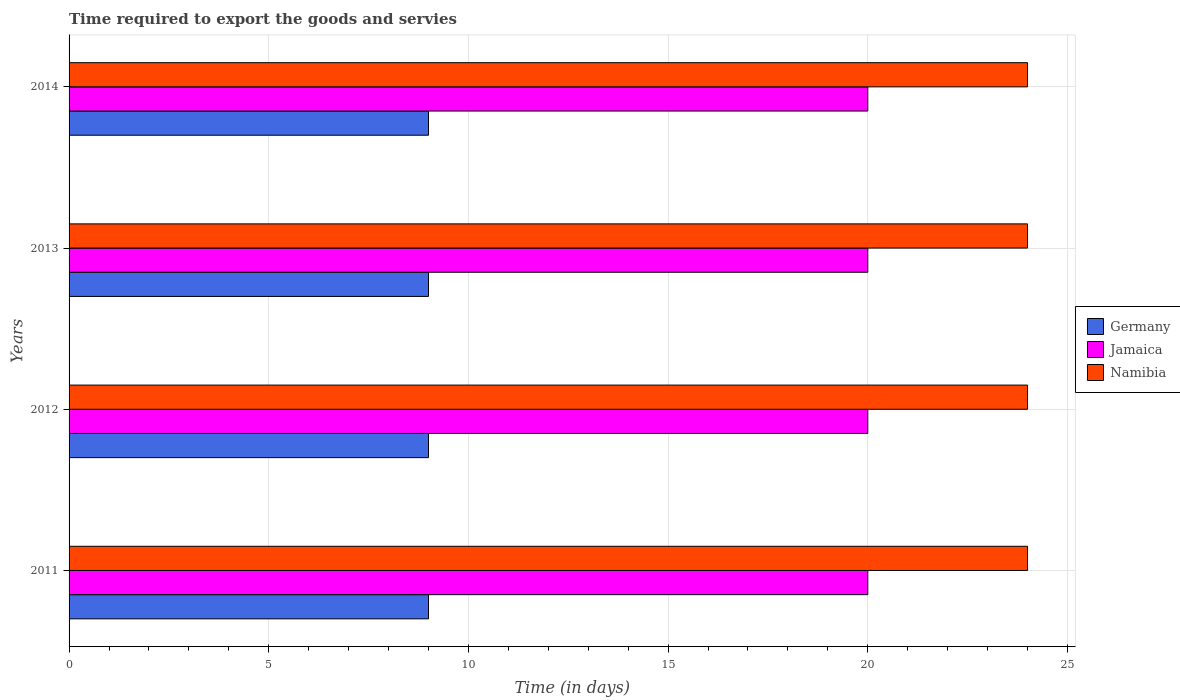How many different coloured bars are there?
Your answer should be compact. 3. Are the number of bars per tick equal to the number of legend labels?
Keep it short and to the point. Yes. Are the number of bars on each tick of the Y-axis equal?
Offer a terse response. Yes. How many bars are there on the 1st tick from the top?
Your answer should be very brief. 3. How many bars are there on the 1st tick from the bottom?
Provide a short and direct response. 3. In how many cases, is the number of bars for a given year not equal to the number of legend labels?
Your response must be concise. 0. What is the number of days required to export the goods and services in Namibia in 2014?
Offer a terse response. 24. Across all years, what is the maximum number of days required to export the goods and services in Germany?
Provide a short and direct response. 9. Across all years, what is the minimum number of days required to export the goods and services in Namibia?
Provide a succinct answer. 24. In which year was the number of days required to export the goods and services in Germany maximum?
Provide a short and direct response. 2011. In which year was the number of days required to export the goods and services in Namibia minimum?
Your response must be concise. 2011. What is the total number of days required to export the goods and services in Namibia in the graph?
Your answer should be compact. 96. What is the difference between the number of days required to export the goods and services in Jamaica in 2013 and the number of days required to export the goods and services in Germany in 2012?
Make the answer very short. 11. What is the average number of days required to export the goods and services in Germany per year?
Provide a short and direct response. 9. In the year 2011, what is the difference between the number of days required to export the goods and services in Germany and number of days required to export the goods and services in Namibia?
Provide a short and direct response. -15. In how many years, is the number of days required to export the goods and services in Jamaica greater than 3 days?
Offer a terse response. 4. What is the ratio of the number of days required to export the goods and services in Jamaica in 2012 to that in 2014?
Ensure brevity in your answer.  1. Is the number of days required to export the goods and services in Jamaica in 2011 less than that in 2012?
Provide a short and direct response. No. Is the difference between the number of days required to export the goods and services in Germany in 2012 and 2014 greater than the difference between the number of days required to export the goods and services in Namibia in 2012 and 2014?
Give a very brief answer. No. What is the difference between the highest and the second highest number of days required to export the goods and services in Germany?
Provide a short and direct response. 0. What is the difference between the highest and the lowest number of days required to export the goods and services in Jamaica?
Ensure brevity in your answer.  0. In how many years, is the number of days required to export the goods and services in Germany greater than the average number of days required to export the goods and services in Germany taken over all years?
Keep it short and to the point. 0. Is it the case that in every year, the sum of the number of days required to export the goods and services in Jamaica and number of days required to export the goods and services in Namibia is greater than the number of days required to export the goods and services in Germany?
Provide a short and direct response. Yes. How many bars are there?
Give a very brief answer. 12. How many years are there in the graph?
Provide a short and direct response. 4. Does the graph contain any zero values?
Offer a terse response. No. What is the title of the graph?
Provide a short and direct response. Time required to export the goods and servies. What is the label or title of the X-axis?
Provide a short and direct response. Time (in days). What is the label or title of the Y-axis?
Provide a succinct answer. Years. What is the Time (in days) of Germany in 2013?
Offer a very short reply. 9. What is the Time (in days) of Namibia in 2013?
Offer a very short reply. 24. What is the Time (in days) of Jamaica in 2014?
Offer a terse response. 20. What is the Time (in days) in Namibia in 2014?
Your response must be concise. 24. Across all years, what is the maximum Time (in days) in Germany?
Keep it short and to the point. 9. Across all years, what is the maximum Time (in days) of Namibia?
Make the answer very short. 24. Across all years, what is the minimum Time (in days) of Germany?
Offer a very short reply. 9. Across all years, what is the minimum Time (in days) in Namibia?
Give a very brief answer. 24. What is the total Time (in days) of Jamaica in the graph?
Offer a very short reply. 80. What is the total Time (in days) of Namibia in the graph?
Your answer should be very brief. 96. What is the difference between the Time (in days) in Jamaica in 2011 and that in 2012?
Make the answer very short. 0. What is the difference between the Time (in days) of Namibia in 2011 and that in 2012?
Offer a terse response. 0. What is the difference between the Time (in days) of Germany in 2011 and that in 2013?
Ensure brevity in your answer.  0. What is the difference between the Time (in days) of Jamaica in 2011 and that in 2014?
Your response must be concise. 0. What is the difference between the Time (in days) in Namibia in 2011 and that in 2014?
Keep it short and to the point. 0. What is the difference between the Time (in days) in Namibia in 2012 and that in 2013?
Keep it short and to the point. 0. What is the difference between the Time (in days) in Jamaica in 2012 and that in 2014?
Your response must be concise. 0. What is the difference between the Time (in days) in Namibia in 2012 and that in 2014?
Make the answer very short. 0. What is the difference between the Time (in days) of Germany in 2013 and that in 2014?
Your answer should be very brief. 0. What is the difference between the Time (in days) of Jamaica in 2013 and that in 2014?
Ensure brevity in your answer.  0. What is the difference between the Time (in days) in Germany in 2011 and the Time (in days) in Jamaica in 2013?
Ensure brevity in your answer.  -11. What is the difference between the Time (in days) in Germany in 2011 and the Time (in days) in Namibia in 2013?
Your answer should be very brief. -15. What is the difference between the Time (in days) in Jamaica in 2011 and the Time (in days) in Namibia in 2013?
Provide a succinct answer. -4. What is the difference between the Time (in days) in Germany in 2011 and the Time (in days) in Jamaica in 2014?
Your answer should be very brief. -11. What is the difference between the Time (in days) of Germany in 2011 and the Time (in days) of Namibia in 2014?
Provide a short and direct response. -15. What is the difference between the Time (in days) in Jamaica in 2011 and the Time (in days) in Namibia in 2014?
Provide a succinct answer. -4. What is the difference between the Time (in days) in Jamaica in 2012 and the Time (in days) in Namibia in 2013?
Make the answer very short. -4. What is the difference between the Time (in days) in Germany in 2012 and the Time (in days) in Jamaica in 2014?
Provide a short and direct response. -11. What is the difference between the Time (in days) in Germany in 2012 and the Time (in days) in Namibia in 2014?
Offer a very short reply. -15. What is the average Time (in days) in Germany per year?
Provide a succinct answer. 9. In the year 2011, what is the difference between the Time (in days) of Germany and Time (in days) of Jamaica?
Make the answer very short. -11. In the year 2011, what is the difference between the Time (in days) of Jamaica and Time (in days) of Namibia?
Make the answer very short. -4. In the year 2012, what is the difference between the Time (in days) of Germany and Time (in days) of Jamaica?
Your answer should be compact. -11. In the year 2012, what is the difference between the Time (in days) in Germany and Time (in days) in Namibia?
Your response must be concise. -15. In the year 2012, what is the difference between the Time (in days) in Jamaica and Time (in days) in Namibia?
Your response must be concise. -4. In the year 2013, what is the difference between the Time (in days) in Germany and Time (in days) in Jamaica?
Your answer should be compact. -11. What is the ratio of the Time (in days) of Namibia in 2011 to that in 2012?
Make the answer very short. 1. What is the ratio of the Time (in days) of Jamaica in 2011 to that in 2014?
Ensure brevity in your answer.  1. What is the ratio of the Time (in days) of Namibia in 2011 to that in 2014?
Your response must be concise. 1. What is the ratio of the Time (in days) of Germany in 2012 to that in 2013?
Ensure brevity in your answer.  1. What is the ratio of the Time (in days) in Jamaica in 2012 to that in 2014?
Provide a short and direct response. 1. What is the difference between the highest and the lowest Time (in days) in Jamaica?
Your answer should be very brief. 0. 